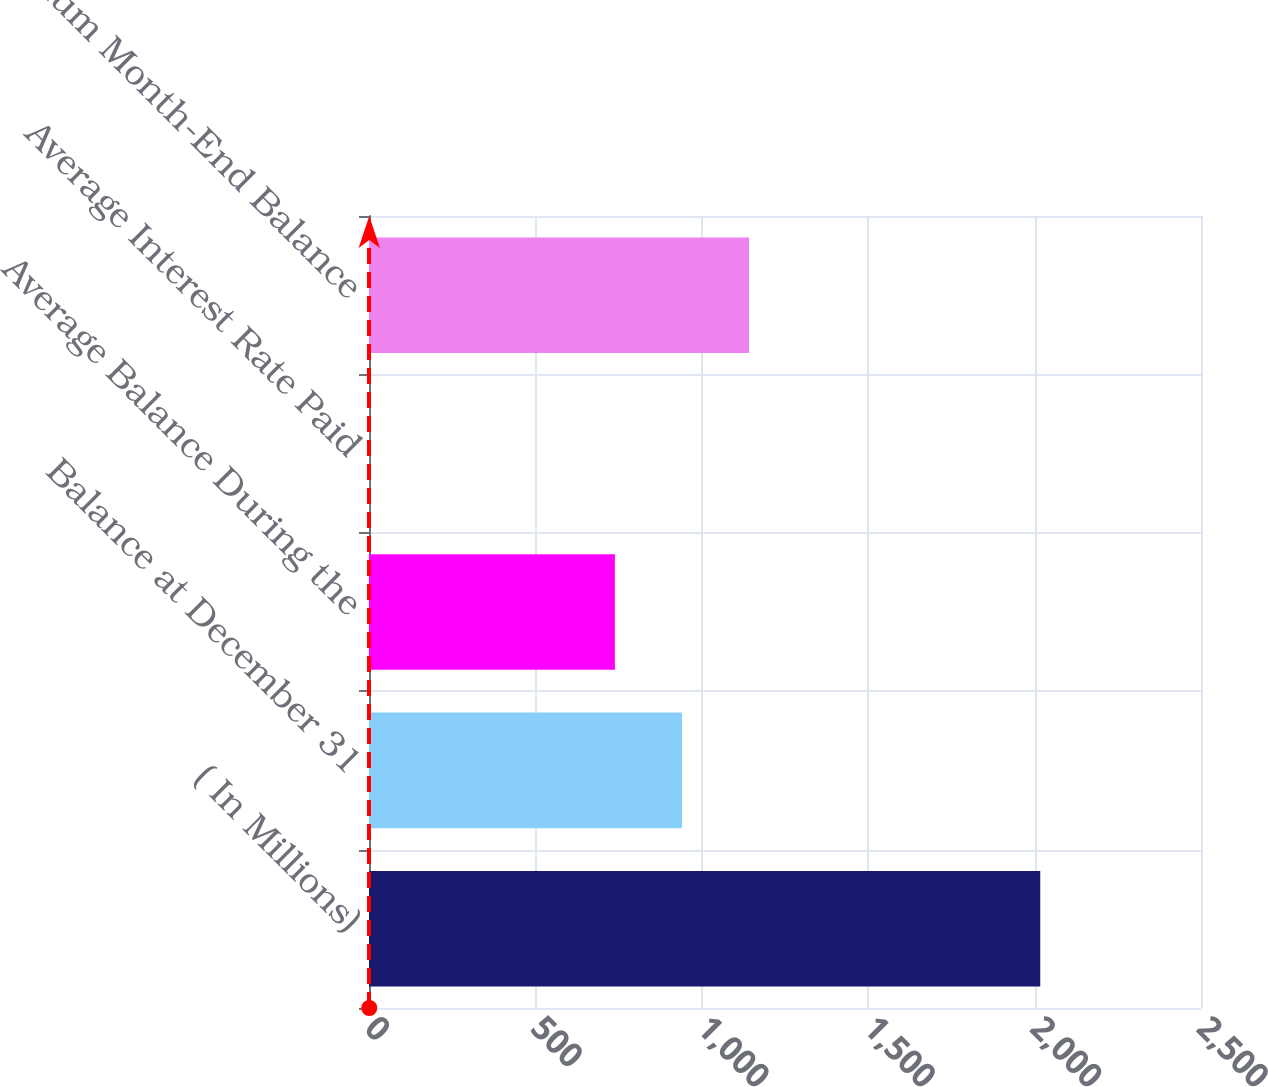Convert chart to OTSL. <chart><loc_0><loc_0><loc_500><loc_500><bar_chart><fcel>( In Millions)<fcel>Balance at December 31<fcel>Average Balance During the<fcel>Average Interest Rate Paid<fcel>Maximum Month-End Balance<nl><fcel>2017<fcel>940.52<fcel>738.9<fcel>0.81<fcel>1142.14<nl></chart> 